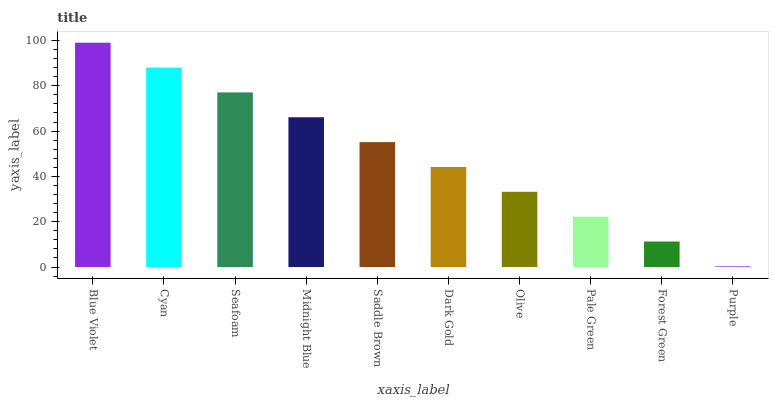Is Purple the minimum?
Answer yes or no. Yes. Is Blue Violet the maximum?
Answer yes or no. Yes. Is Cyan the minimum?
Answer yes or no. No. Is Cyan the maximum?
Answer yes or no. No. Is Blue Violet greater than Cyan?
Answer yes or no. Yes. Is Cyan less than Blue Violet?
Answer yes or no. Yes. Is Cyan greater than Blue Violet?
Answer yes or no. No. Is Blue Violet less than Cyan?
Answer yes or no. No. Is Saddle Brown the high median?
Answer yes or no. Yes. Is Dark Gold the low median?
Answer yes or no. Yes. Is Blue Violet the high median?
Answer yes or no. No. Is Blue Violet the low median?
Answer yes or no. No. 